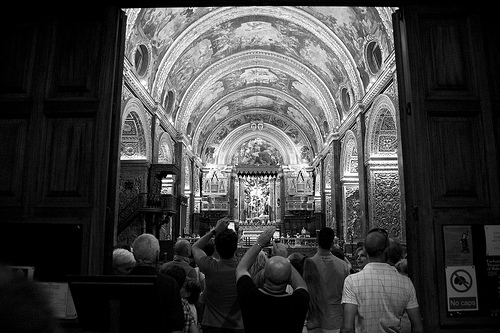If you were to attend a service here, describe what you might see and feel. Attending a service here, you would be enveloped by the grandeur of the place. The majestic vaulted ceilings adorned with detailed frescoes would draw your eyes upward, while the quiet murmur of prayers and the soft glow of candlelight create an ambiance of solemnity and peace. The scent of incense might linger in the air, adding to the spiritual atmosphere as the serene hymns resonate through the vast space. 